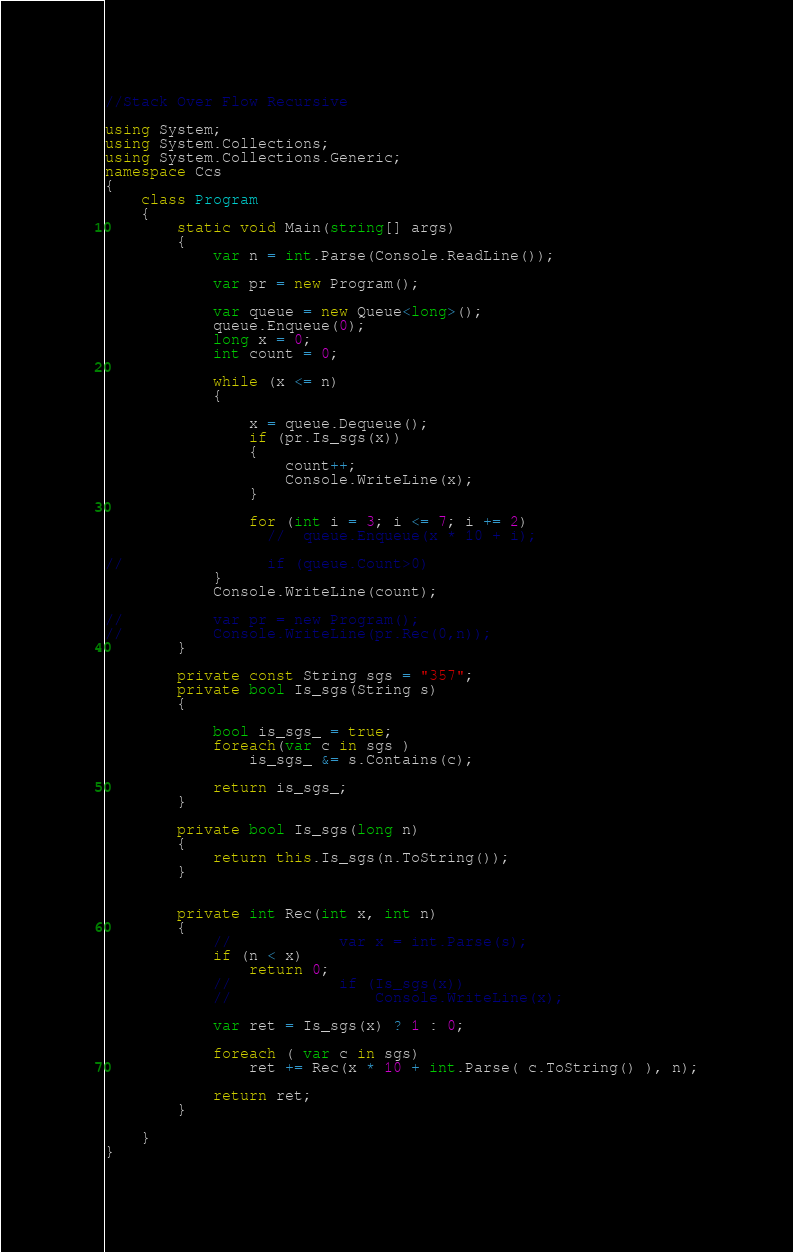Convert code to text. <code><loc_0><loc_0><loc_500><loc_500><_C#_>
//Stack Over Flow Recursive

using System;
using System.Collections;
using System.Collections.Generic;
namespace Ccs
{
    class Program
    {
        static void Main(string[] args)
        {
            var n = int.Parse(Console.ReadLine());

            var pr = new Program();

            var queue = new Queue<long>();
            queue.Enqueue(0);
            long x = 0;
            int count = 0;

            while (x <= n)
            {

                x = queue.Dequeue();
                if (pr.Is_sgs(x))
                {
                    count++;
                    Console.WriteLine(x);
                }

                for (int i = 3; i <= 7; i += 2)
                  //  queue.Enqueue(x * 10 + i);

//                if (queue.Count>0)
            }
            Console.WriteLine(count);

//          var pr = new Program();
//          Console.WriteLine(pr.Rec(0,n));
        }

        private const String sgs = "357";
        private bool Is_sgs(String s)
        {
           
            bool is_sgs_ = true;
            foreach(var c in sgs )
                is_sgs_ &= s.Contains(c);
           
            return is_sgs_;
        }   
        
        private bool Is_sgs(long n)
        {
            return this.Is_sgs(n.ToString());
        }


        private int Rec(int x, int n)
        {
            //            var x = int.Parse(s);
            if (n < x)
                return 0;
            //            if (Is_sgs(x))
            //                Console.WriteLine(x);

            var ret = Is_sgs(x) ? 1 : 0;

            foreach ( var c in sgs)
                ret += Rec(x * 10 + int.Parse( c.ToString() ), n);

            return ret;
        }

    }
}
</code> 